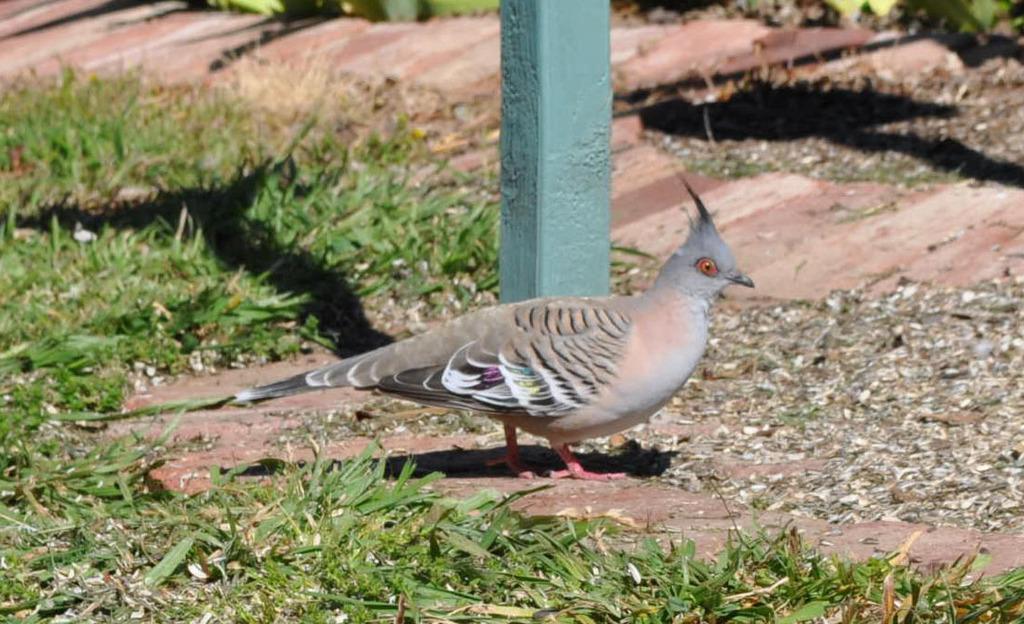In one or two sentences, can you explain what this image depicts? In this image, we can see a bird. We can see a pole and the ground with some objects. We can also see some grass. 